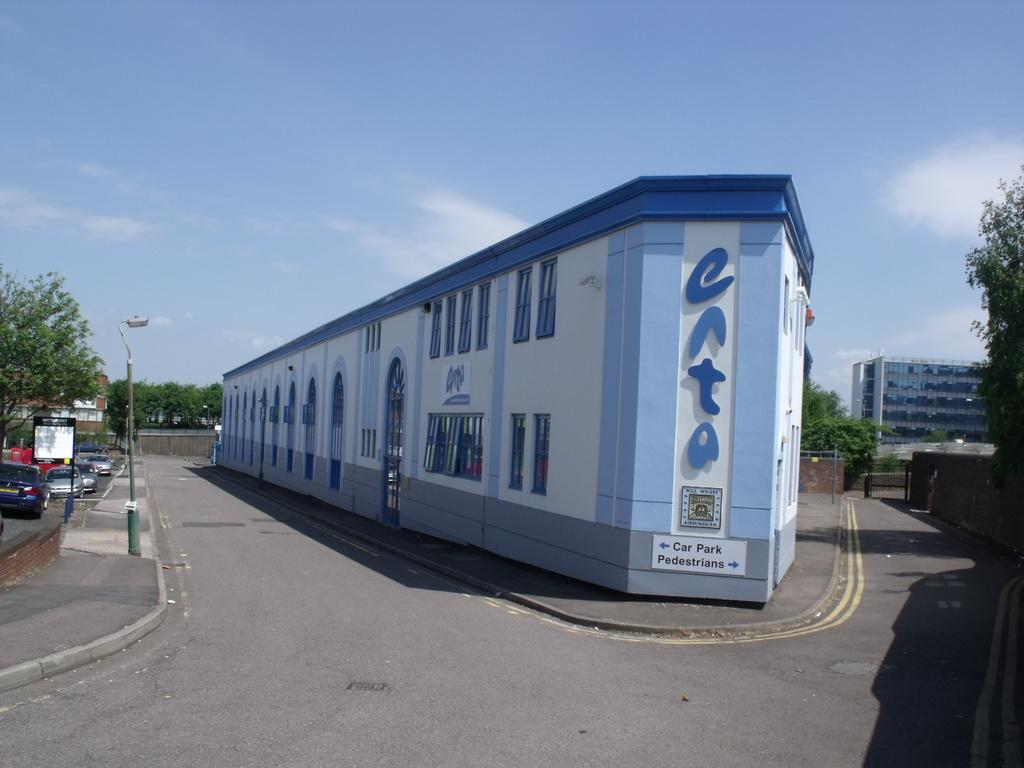<image>
Summarize the visual content of the image. A sign outside of a building show where to park your car and where pedestrians should go. 